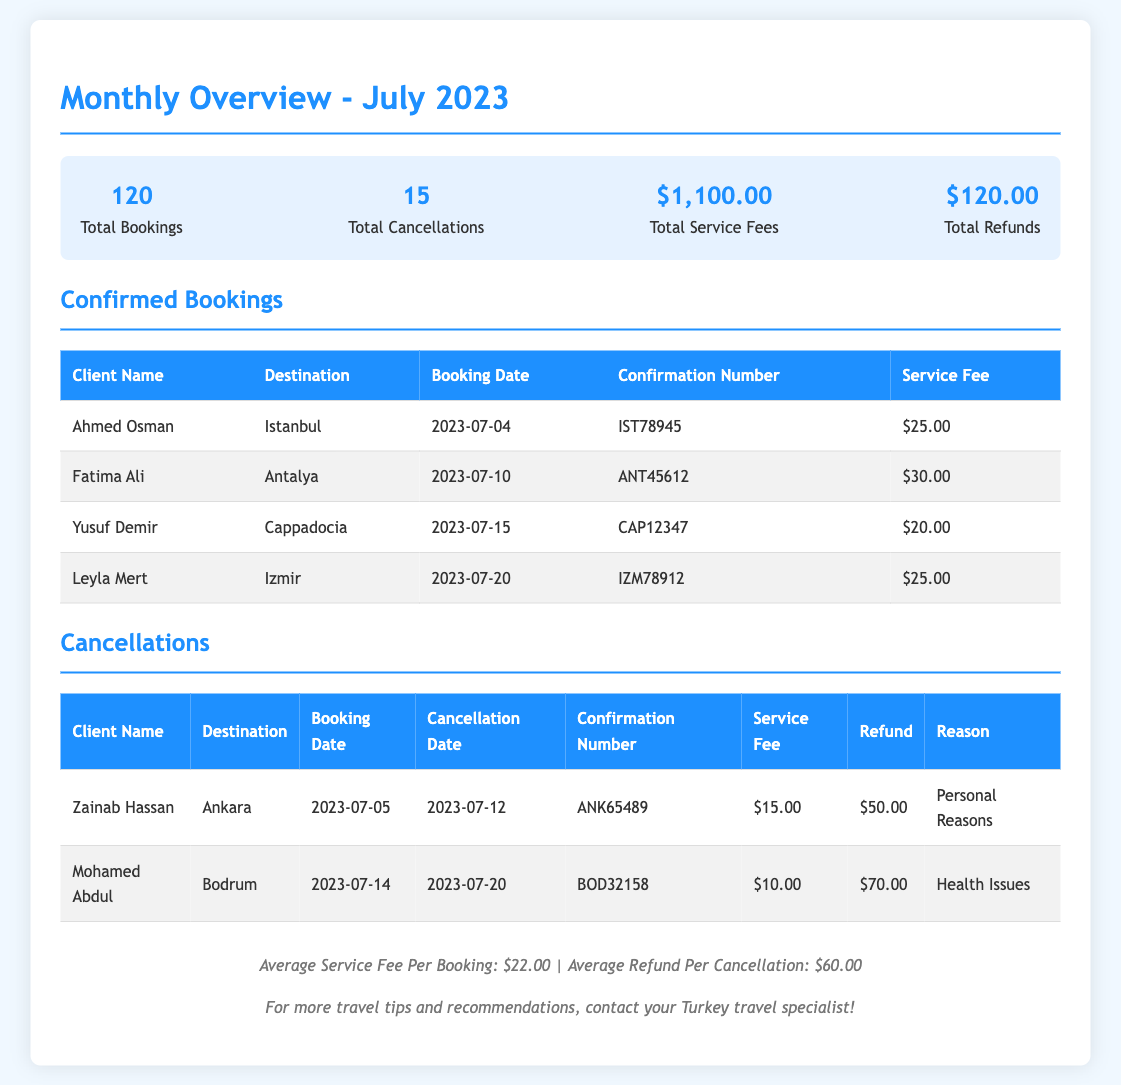What is the total number of bookings? The total number of bookings is explicitly stated in the summary section of the document.
Answer: 120 How many cancellations occurred in July 2023? The total number of cancellations is provided in the summary section of the document.
Answer: 15 What was the total service fees collected? The total service fees amount can be found in the summary section of the document.
Answer: $1,100.00 What is the average refund per cancellation? The average refund per cancellation is given in the footer of the document.
Answer: $60.00 Who booked a trip to Cappadocia? This information can be retrieved from the confirmed bookings table in the document.
Answer: Yusuf Demir What was the service fee for Fatima Ali's booking? The service fee for the specific client's booking can be found in the confirmed bookings table.
Answer: $30.00 What was the reason for Mohamed Abdul's cancellation? The reason for cancellation is listed in the cancellations table of the document.
Answer: Health Issues What is the confirmation number for Ahmed Osman's booking? The confirmation number can be found in the confirmed bookings table associated with the client's name.
Answer: IST78945 How many clients received refunds in July 2023? This can be inferred by looking at the cancellations table where refunds were detailed.
Answer: 2 